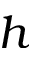<formula> <loc_0><loc_0><loc_500><loc_500>h</formula> 